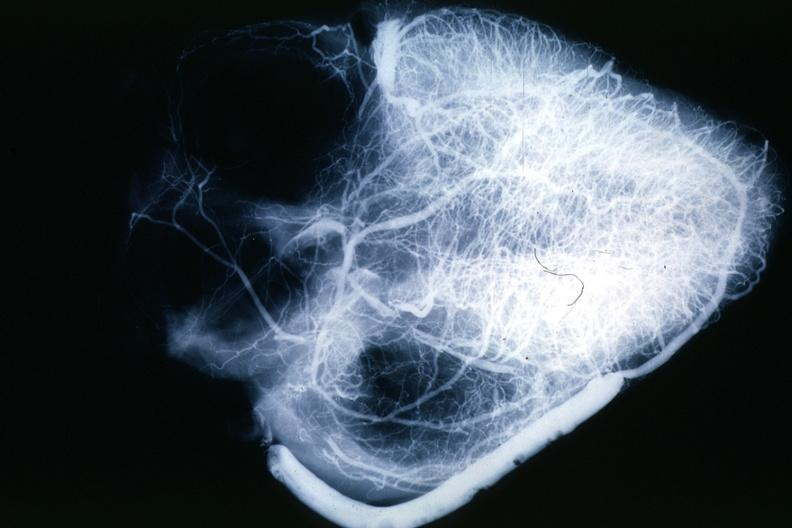s myocardium present?
Answer the question using a single word or phrase. No 